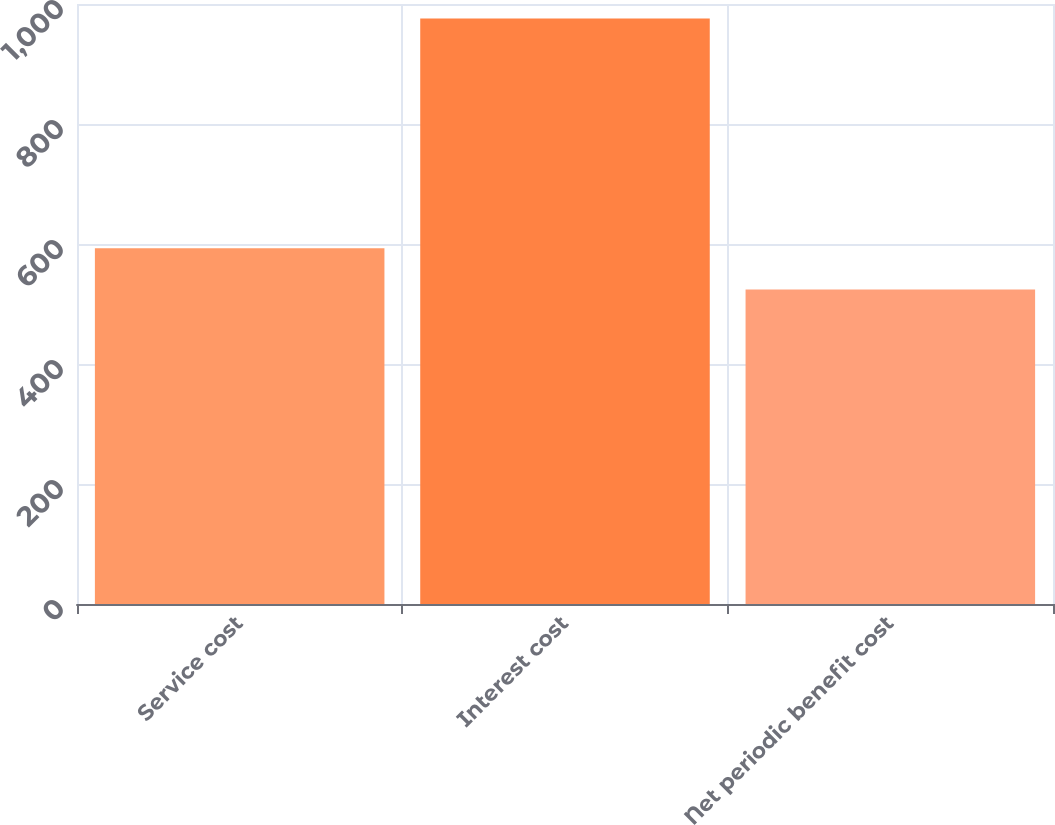Convert chart. <chart><loc_0><loc_0><loc_500><loc_500><bar_chart><fcel>Service cost<fcel>Interest cost<fcel>Net periodic benefit cost<nl><fcel>593<fcel>976<fcel>524<nl></chart> 